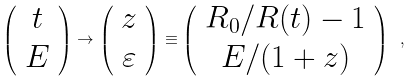<formula> <loc_0><loc_0><loc_500><loc_500>\left ( \begin{array} { c } t \\ E \end{array} \right ) \to \left ( \begin{array} { c } z \\ \varepsilon \end{array} \right ) \equiv \left ( \begin{array} { c } R _ { 0 } / R ( t ) - 1 \\ E / ( 1 + z ) \end{array} \right ) \ ,</formula> 